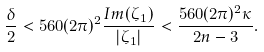<formula> <loc_0><loc_0><loc_500><loc_500>\frac { \delta } { 2 } < 5 6 0 ( 2 \pi ) ^ { 2 } \frac { I m ( \zeta _ { 1 } ) } { | \zeta _ { 1 } | } < \frac { 5 6 0 ( 2 \pi ) ^ { 2 } \kappa } { 2 n - 3 } .</formula> 